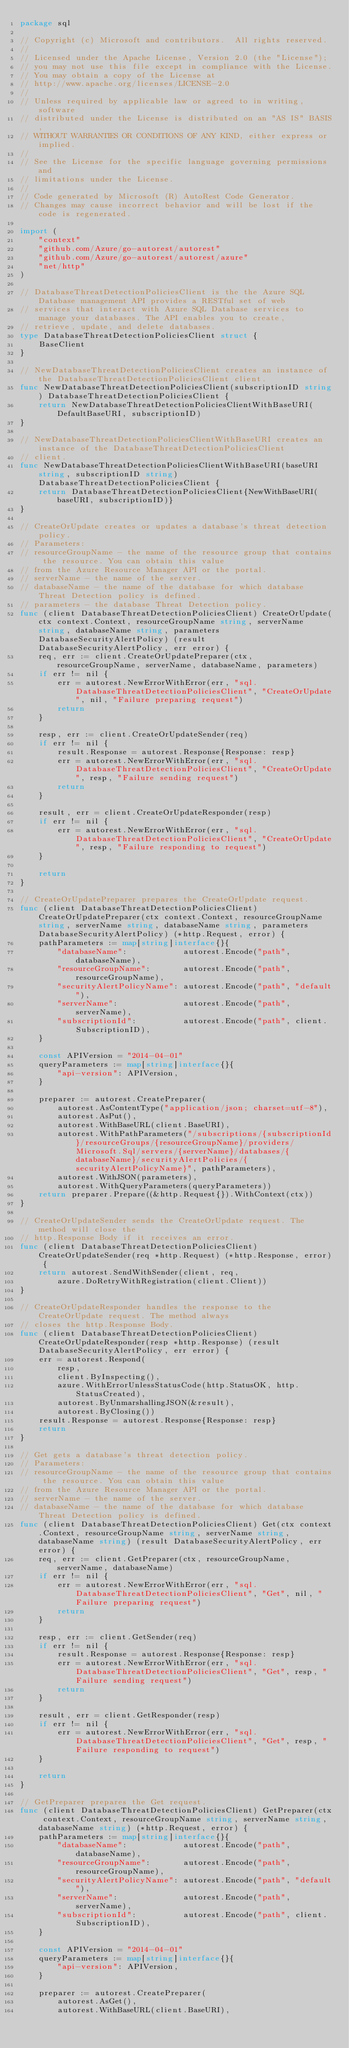<code> <loc_0><loc_0><loc_500><loc_500><_Go_>package sql

// Copyright (c) Microsoft and contributors.  All rights reserved.
//
// Licensed under the Apache License, Version 2.0 (the "License");
// you may not use this file except in compliance with the License.
// You may obtain a copy of the License at
// http://www.apache.org/licenses/LICENSE-2.0
//
// Unless required by applicable law or agreed to in writing, software
// distributed under the License is distributed on an "AS IS" BASIS,
// WITHOUT WARRANTIES OR CONDITIONS OF ANY KIND, either express or implied.
//
// See the License for the specific language governing permissions and
// limitations under the License.
//
// Code generated by Microsoft (R) AutoRest Code Generator.
// Changes may cause incorrect behavior and will be lost if the code is regenerated.

import (
	"context"
	"github.com/Azure/go-autorest/autorest"
	"github.com/Azure/go-autorest/autorest/azure"
	"net/http"
)

// DatabaseThreatDetectionPoliciesClient is the the Azure SQL Database management API provides a RESTful set of web
// services that interact with Azure SQL Database services to manage your databases. The API enables you to create,
// retrieve, update, and delete databases.
type DatabaseThreatDetectionPoliciesClient struct {
	BaseClient
}

// NewDatabaseThreatDetectionPoliciesClient creates an instance of the DatabaseThreatDetectionPoliciesClient client.
func NewDatabaseThreatDetectionPoliciesClient(subscriptionID string) DatabaseThreatDetectionPoliciesClient {
	return NewDatabaseThreatDetectionPoliciesClientWithBaseURI(DefaultBaseURI, subscriptionID)
}

// NewDatabaseThreatDetectionPoliciesClientWithBaseURI creates an instance of the DatabaseThreatDetectionPoliciesClient
// client.
func NewDatabaseThreatDetectionPoliciesClientWithBaseURI(baseURI string, subscriptionID string) DatabaseThreatDetectionPoliciesClient {
	return DatabaseThreatDetectionPoliciesClient{NewWithBaseURI(baseURI, subscriptionID)}
}

// CreateOrUpdate creates or updates a database's threat detection policy.
// Parameters:
// resourceGroupName - the name of the resource group that contains the resource. You can obtain this value
// from the Azure Resource Manager API or the portal.
// serverName - the name of the server.
// databaseName - the name of the database for which database Threat Detection policy is defined.
// parameters - the database Threat Detection policy.
func (client DatabaseThreatDetectionPoliciesClient) CreateOrUpdate(ctx context.Context, resourceGroupName string, serverName string, databaseName string, parameters DatabaseSecurityAlertPolicy) (result DatabaseSecurityAlertPolicy, err error) {
	req, err := client.CreateOrUpdatePreparer(ctx, resourceGroupName, serverName, databaseName, parameters)
	if err != nil {
		err = autorest.NewErrorWithError(err, "sql.DatabaseThreatDetectionPoliciesClient", "CreateOrUpdate", nil, "Failure preparing request")
		return
	}

	resp, err := client.CreateOrUpdateSender(req)
	if err != nil {
		result.Response = autorest.Response{Response: resp}
		err = autorest.NewErrorWithError(err, "sql.DatabaseThreatDetectionPoliciesClient", "CreateOrUpdate", resp, "Failure sending request")
		return
	}

	result, err = client.CreateOrUpdateResponder(resp)
	if err != nil {
		err = autorest.NewErrorWithError(err, "sql.DatabaseThreatDetectionPoliciesClient", "CreateOrUpdate", resp, "Failure responding to request")
	}

	return
}

// CreateOrUpdatePreparer prepares the CreateOrUpdate request.
func (client DatabaseThreatDetectionPoliciesClient) CreateOrUpdatePreparer(ctx context.Context, resourceGroupName string, serverName string, databaseName string, parameters DatabaseSecurityAlertPolicy) (*http.Request, error) {
	pathParameters := map[string]interface{}{
		"databaseName":            autorest.Encode("path", databaseName),
		"resourceGroupName":       autorest.Encode("path", resourceGroupName),
		"securityAlertPolicyName": autorest.Encode("path", "default"),
		"serverName":              autorest.Encode("path", serverName),
		"subscriptionId":          autorest.Encode("path", client.SubscriptionID),
	}

	const APIVersion = "2014-04-01"
	queryParameters := map[string]interface{}{
		"api-version": APIVersion,
	}

	preparer := autorest.CreatePreparer(
		autorest.AsContentType("application/json; charset=utf-8"),
		autorest.AsPut(),
		autorest.WithBaseURL(client.BaseURI),
		autorest.WithPathParameters("/subscriptions/{subscriptionId}/resourceGroups/{resourceGroupName}/providers/Microsoft.Sql/servers/{serverName}/databases/{databaseName}/securityAlertPolicies/{securityAlertPolicyName}", pathParameters),
		autorest.WithJSON(parameters),
		autorest.WithQueryParameters(queryParameters))
	return preparer.Prepare((&http.Request{}).WithContext(ctx))
}

// CreateOrUpdateSender sends the CreateOrUpdate request. The method will close the
// http.Response Body if it receives an error.
func (client DatabaseThreatDetectionPoliciesClient) CreateOrUpdateSender(req *http.Request) (*http.Response, error) {
	return autorest.SendWithSender(client, req,
		azure.DoRetryWithRegistration(client.Client))
}

// CreateOrUpdateResponder handles the response to the CreateOrUpdate request. The method always
// closes the http.Response Body.
func (client DatabaseThreatDetectionPoliciesClient) CreateOrUpdateResponder(resp *http.Response) (result DatabaseSecurityAlertPolicy, err error) {
	err = autorest.Respond(
		resp,
		client.ByInspecting(),
		azure.WithErrorUnlessStatusCode(http.StatusOK, http.StatusCreated),
		autorest.ByUnmarshallingJSON(&result),
		autorest.ByClosing())
	result.Response = autorest.Response{Response: resp}
	return
}

// Get gets a database's threat detection policy.
// Parameters:
// resourceGroupName - the name of the resource group that contains the resource. You can obtain this value
// from the Azure Resource Manager API or the portal.
// serverName - the name of the server.
// databaseName - the name of the database for which database Threat Detection policy is defined.
func (client DatabaseThreatDetectionPoliciesClient) Get(ctx context.Context, resourceGroupName string, serverName string, databaseName string) (result DatabaseSecurityAlertPolicy, err error) {
	req, err := client.GetPreparer(ctx, resourceGroupName, serverName, databaseName)
	if err != nil {
		err = autorest.NewErrorWithError(err, "sql.DatabaseThreatDetectionPoliciesClient", "Get", nil, "Failure preparing request")
		return
	}

	resp, err := client.GetSender(req)
	if err != nil {
		result.Response = autorest.Response{Response: resp}
		err = autorest.NewErrorWithError(err, "sql.DatabaseThreatDetectionPoliciesClient", "Get", resp, "Failure sending request")
		return
	}

	result, err = client.GetResponder(resp)
	if err != nil {
		err = autorest.NewErrorWithError(err, "sql.DatabaseThreatDetectionPoliciesClient", "Get", resp, "Failure responding to request")
	}

	return
}

// GetPreparer prepares the Get request.
func (client DatabaseThreatDetectionPoliciesClient) GetPreparer(ctx context.Context, resourceGroupName string, serverName string, databaseName string) (*http.Request, error) {
	pathParameters := map[string]interface{}{
		"databaseName":            autorest.Encode("path", databaseName),
		"resourceGroupName":       autorest.Encode("path", resourceGroupName),
		"securityAlertPolicyName": autorest.Encode("path", "default"),
		"serverName":              autorest.Encode("path", serverName),
		"subscriptionId":          autorest.Encode("path", client.SubscriptionID),
	}

	const APIVersion = "2014-04-01"
	queryParameters := map[string]interface{}{
		"api-version": APIVersion,
	}

	preparer := autorest.CreatePreparer(
		autorest.AsGet(),
		autorest.WithBaseURL(client.BaseURI),</code> 